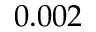<formula> <loc_0><loc_0><loc_500><loc_500>0 . 0 0 2</formula> 